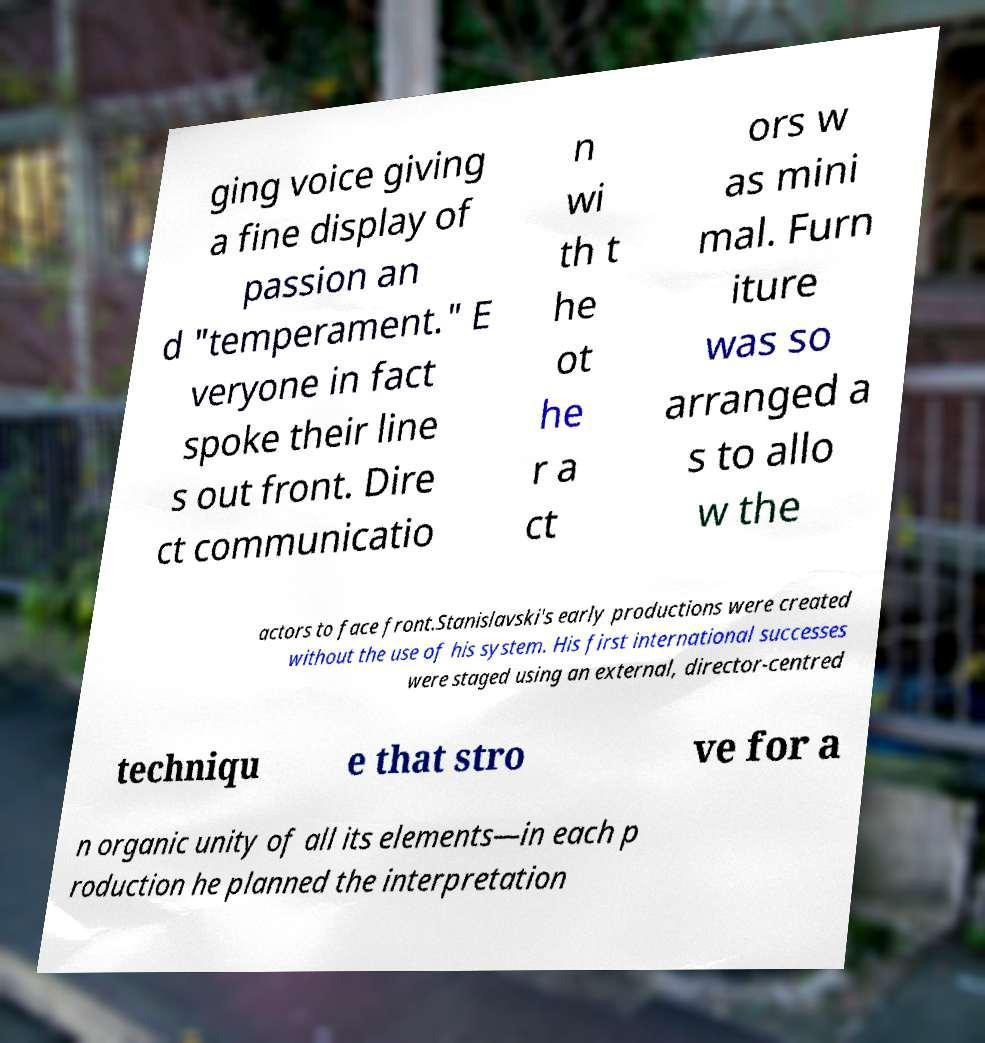Could you extract and type out the text from this image? ging voice giving a fine display of passion an d "temperament." E veryone in fact spoke their line s out front. Dire ct communicatio n wi th t he ot he r a ct ors w as mini mal. Furn iture was so arranged a s to allo w the actors to face front.Stanislavski's early productions were created without the use of his system. His first international successes were staged using an external, director-centred techniqu e that stro ve for a n organic unity of all its elements—in each p roduction he planned the interpretation 